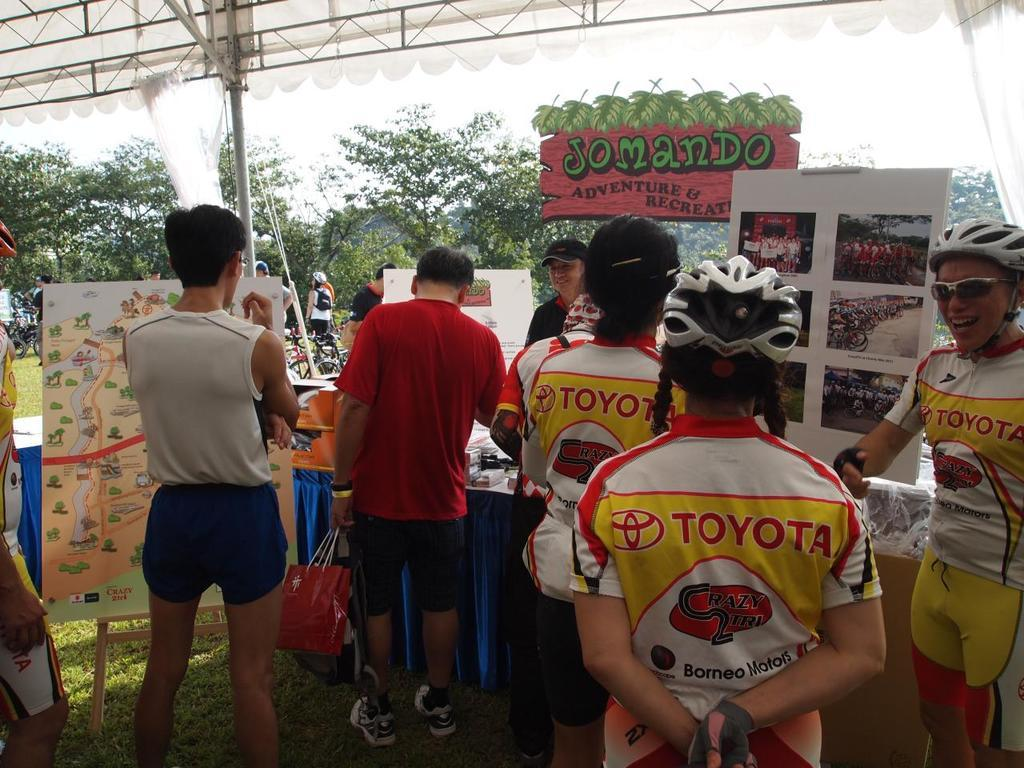Provide a one-sentence caption for the provided image. The cyclists have a Toyota ad on their uniforms. 